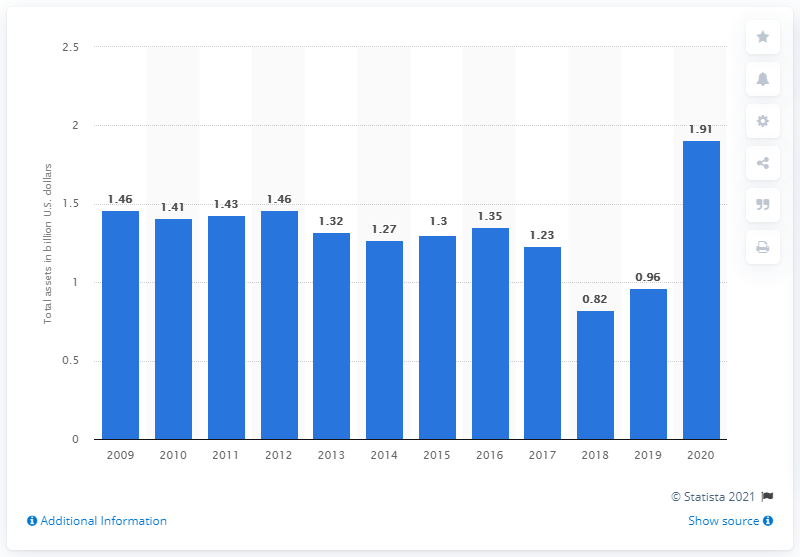Point out several critical features in this image. In 2020, Jack in the Box Inc.'s value was approximately 1.91 billion dollars. 